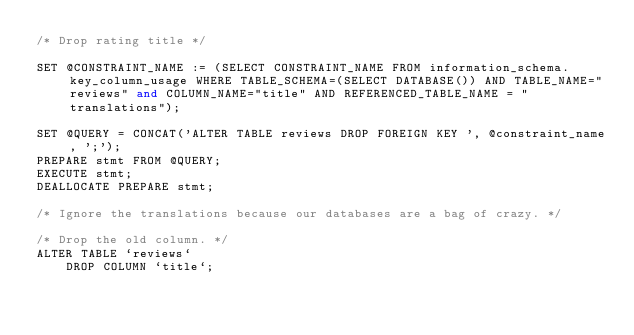<code> <loc_0><loc_0><loc_500><loc_500><_SQL_>/* Drop rating title */

SET @CONSTRAINT_NAME := (SELECT CONSTRAINT_NAME FROM information_schema.key_column_usage WHERE TABLE_SCHEMA=(SELECT DATABASE()) AND TABLE_NAME="reviews" and COLUMN_NAME="title" AND REFERENCED_TABLE_NAME = "translations");

SET @QUERY = CONCAT('ALTER TABLE reviews DROP FOREIGN KEY ', @constraint_name, ';');
PREPARE stmt FROM @QUERY;
EXECUTE stmt;
DEALLOCATE PREPARE stmt;

/* Ignore the translations because our databases are a bag of crazy. */

/* Drop the old column. */
ALTER TABLE `reviews`
    DROP COLUMN `title`;
</code> 